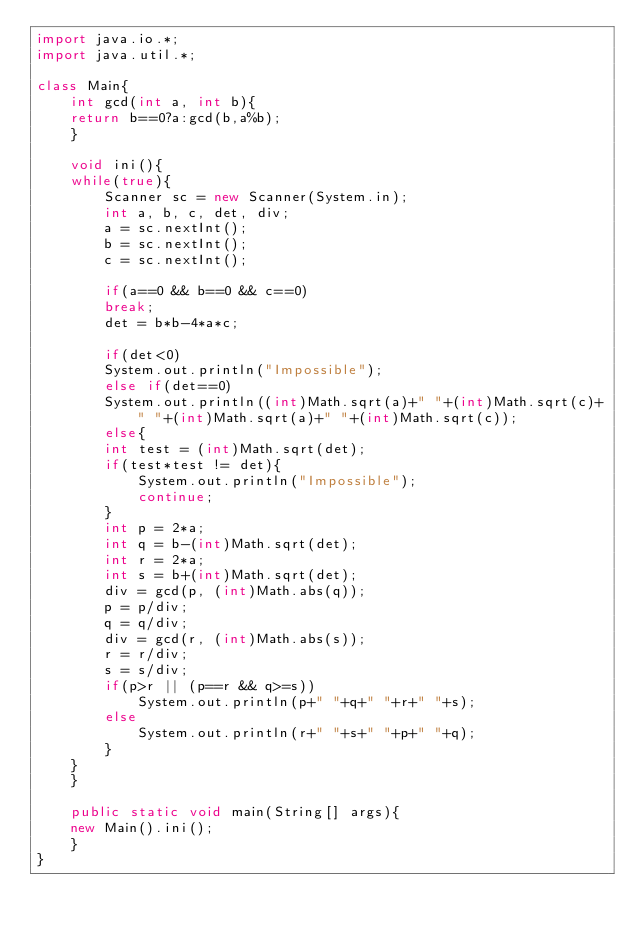Convert code to text. <code><loc_0><loc_0><loc_500><loc_500><_Java_>import java.io.*;
import java.util.*;

class Main{
    int gcd(int a, int b){
	return b==0?a:gcd(b,a%b);
    }
    
    void ini(){
	while(true){
	    Scanner sc = new Scanner(System.in);
	    int a, b, c, det, div;
	    a = sc.nextInt();
	    b = sc.nextInt();
	    c = sc.nextInt();
	    
	    if(a==0 && b==0 && c==0)
		break;
	    det = b*b-4*a*c;
	    
	    if(det<0)
		System.out.println("Impossible");
	    else if(det==0)
		System.out.println((int)Math.sqrt(a)+" "+(int)Math.sqrt(c)+" "+(int)Math.sqrt(a)+" "+(int)Math.sqrt(c));
	    else{
		int test = (int)Math.sqrt(det);
		if(test*test != det){
		    System.out.println("Impossible");
		    continue;
		}
		int p = 2*a;
		int q = b-(int)Math.sqrt(det);
		int r = 2*a;
		int s = b+(int)Math.sqrt(det);
		div = gcd(p, (int)Math.abs(q));
		p = p/div;
		q = q/div;
		div = gcd(r, (int)Math.abs(s));
		r = r/div;
		s = s/div;
		if(p>r || (p==r && q>=s))
		    System.out.println(p+" "+q+" "+r+" "+s);
		else
		    System.out.println(r+" "+s+" "+p+" "+q);
	    }
	}
    }
    
    public static void main(String[] args){
	new Main().ini();
    }
}</code> 